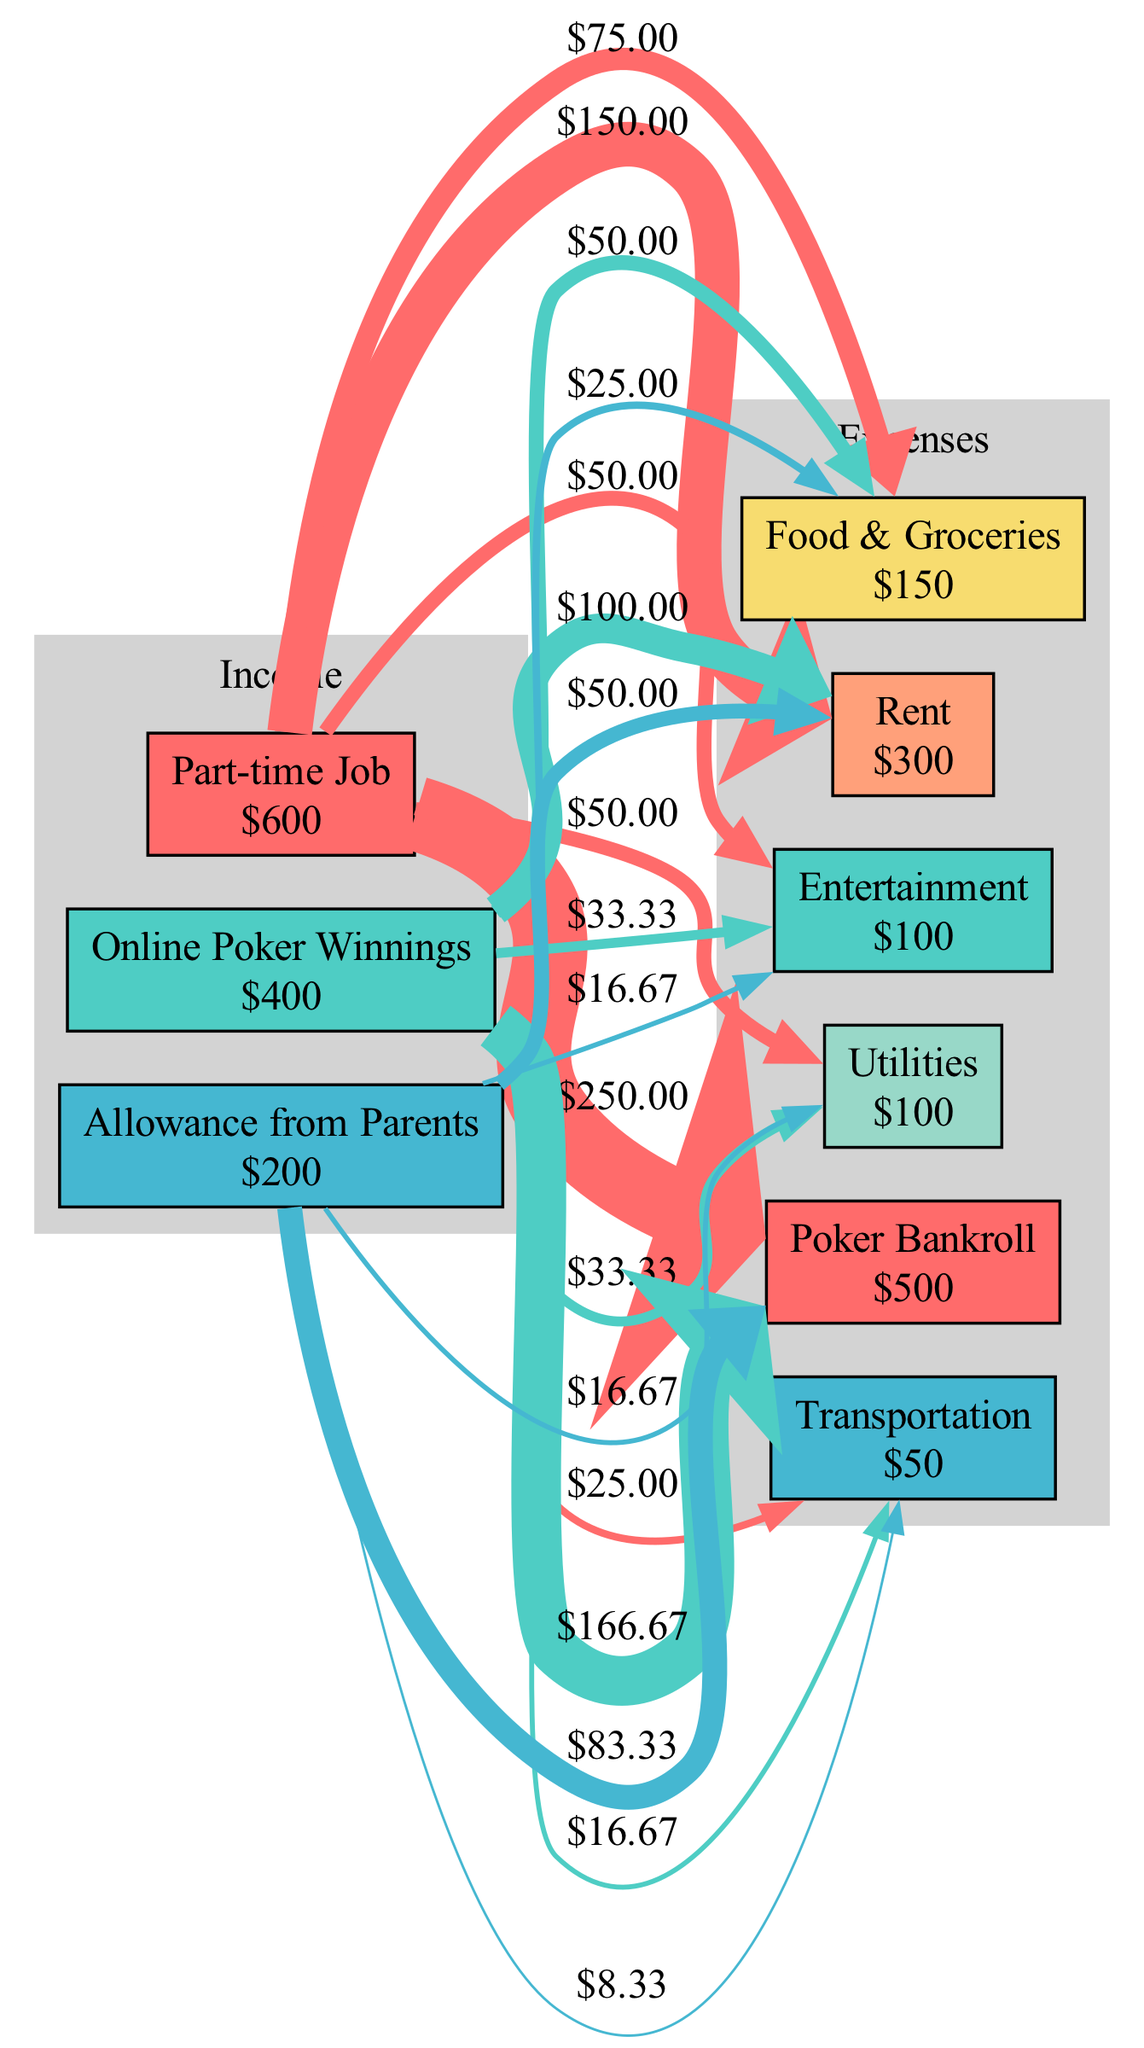What is the total monthly income? To find the total monthly income, sum up all the income sources: Part-time Job ($600), Online Poker Winnings ($400), and Allowance from Parents ($200). The calculation is 600 + 400 + 200 = 1200.
Answer: 1200 Which expense category has the highest allocation? The highest expense category is the Poker Bankroll, which is allocated $500. This is visually represented as the thickest line pointing to the corresponding expense node.
Answer: Poker Bankroll How much does the Online Poker Winnings contribute to the Poker Bankroll? The Online Poker Winnings source contributes $133.33 to the Poker Bankroll. This is calculated as follows: (Online Poker Winnings amount / Total income) * Poker Bankroll amount, which is (400 / 1200) * 500 = 133.33.
Answer: 133.33 How many expense categories are there? There are six expense categories as indicated by the six distinct nodes labeled Rent, Utilities, Food & Groceries, Poker Bankroll, Entertainment, and Transportation, all connected to the income sources.
Answer: 6 What percentage of the total income is allocated to Food & Groceries? To find the percentage allocated to Food & Groceries, first calculate its contribution from the income sources, which is 125.00, then divide by the total income (1200) and multiply by 100. The calculation is (150 / 1200) * 100 = 12.5%.
Answer: 12.5% What is the total amount allocated to entertainment and transportation? To find this, add the amounts allocated to both categories: Entertainment ($100) plus Transportation ($50), which equals 150.
Answer: 150 Which income source contributes the least? The income source that contributes the least is the Allowance from Parents, which is $200. This is the smallest box in the income section of the diagram.
Answer: Allowance from Parents What is the total amount spent on rent and utilities together? The total amount spent on Rent ($300) and Utilities ($100) is 300 + 100 = 400.
Answer: 400 How is the total income distributed among the expense categories? The total income of $1200 is distributed through various flows to each category based on the original amounts, with Poker Bankroll receiving the largest share followed by Rent, Food & Groceries, and others. Each flow is proportional to the source node contributions.
Answer: Proportional distribution 